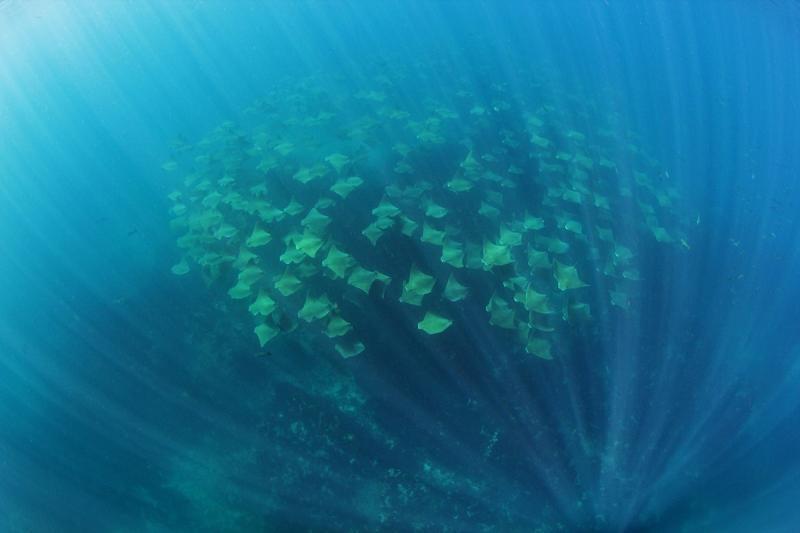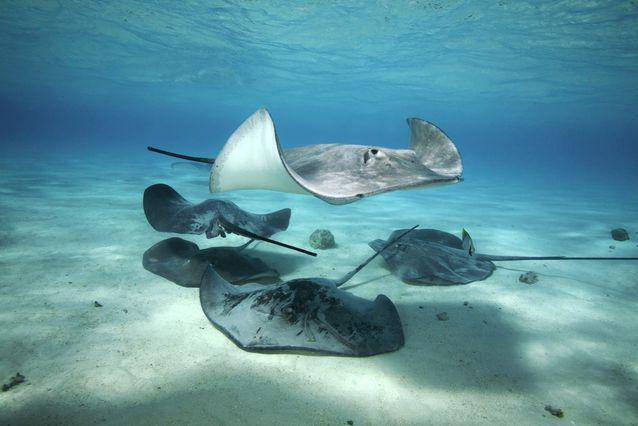The first image is the image on the left, the second image is the image on the right. Considering the images on both sides, is "There are no more than eight creatures in the image on the right." valid? Answer yes or no. Yes. 